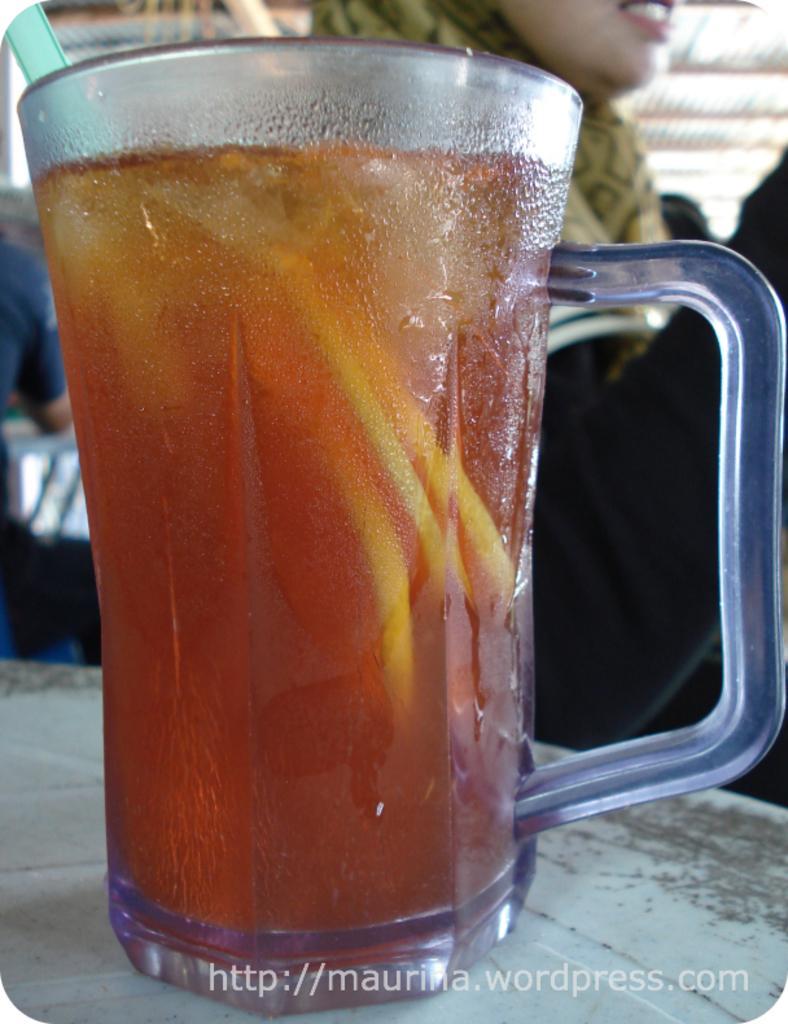Describe this image in one or two sentences. In this image we can see a glass of liquid with a straw on the table. In the background we can see a woman. At the bottom there is text. 